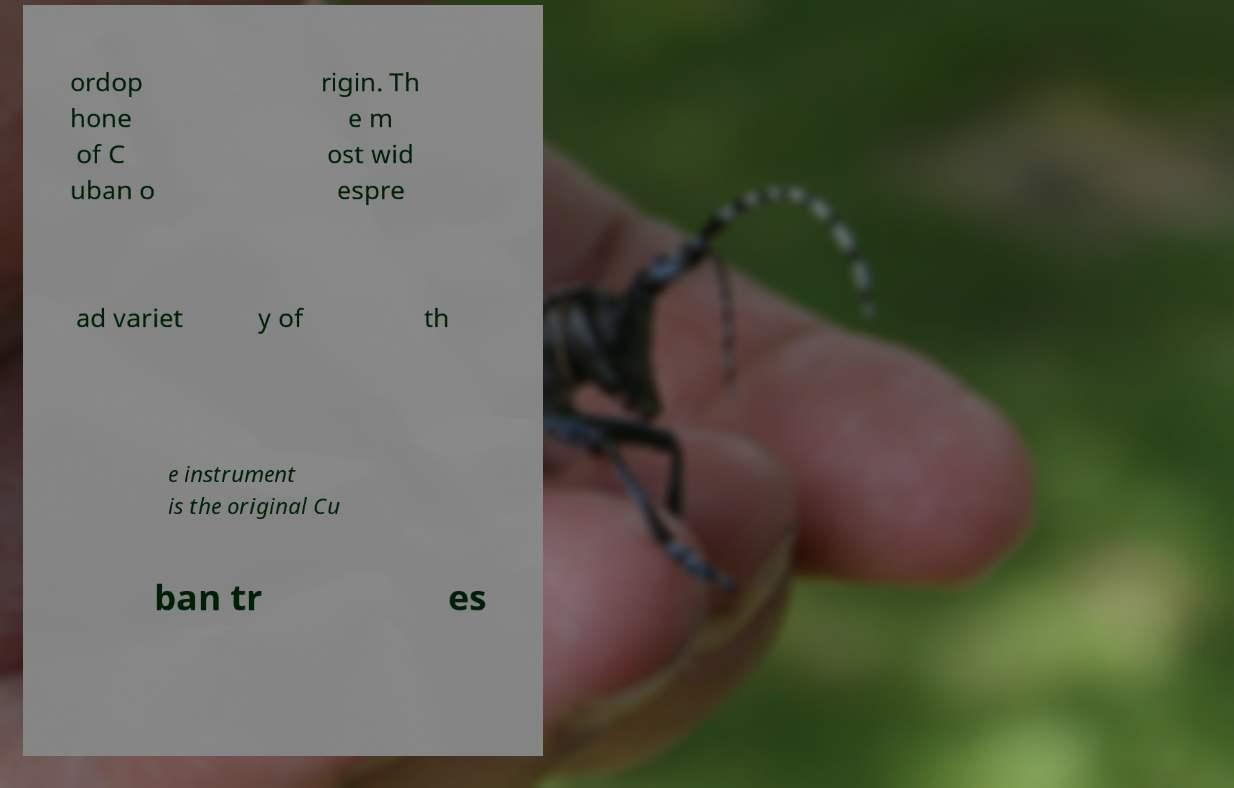I need the written content from this picture converted into text. Can you do that? ordop hone of C uban o rigin. Th e m ost wid espre ad variet y of th e instrument is the original Cu ban tr es 